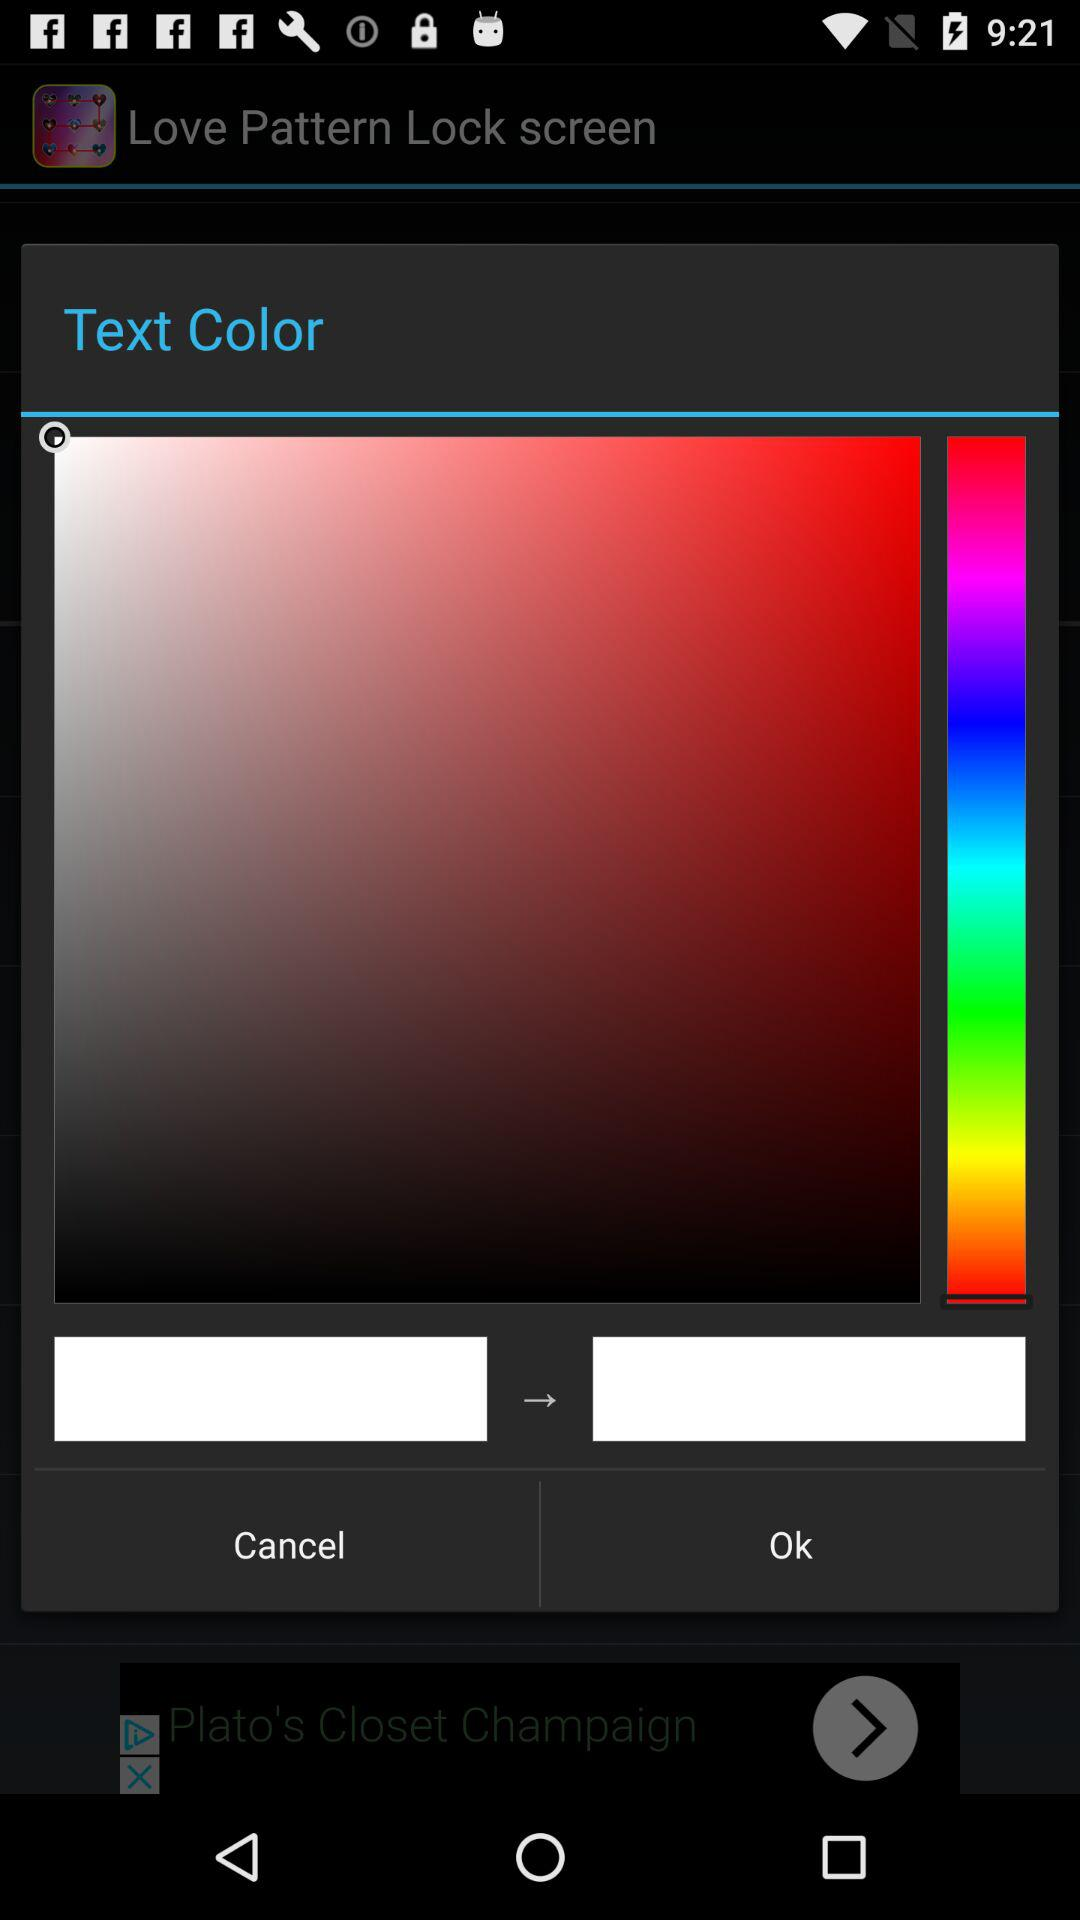How many text inputs are on the screen?
Answer the question using a single word or phrase. 2 